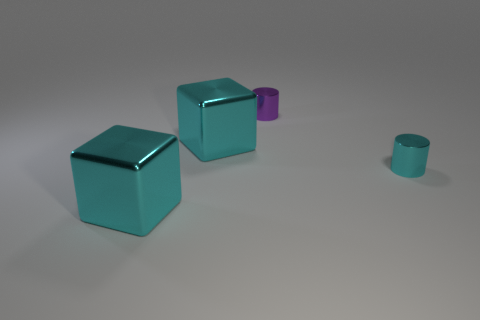If these objects were part of a larger setting, what sort of environment do you imagine they would be in? Given their pristine condition and geometric precision, these objects could belong to a minimalistic art installation, or perhaps they're part of a modern, high-concept design space with a focus on form and color interaction. How might these objects be used in a practical sense, if at all? If these objects have a practical purpose, the cubes could serve as stylish, contemporary furniture pieces like side tables, while the cylindrical objects might be decorative vases or sophisticated containers. 